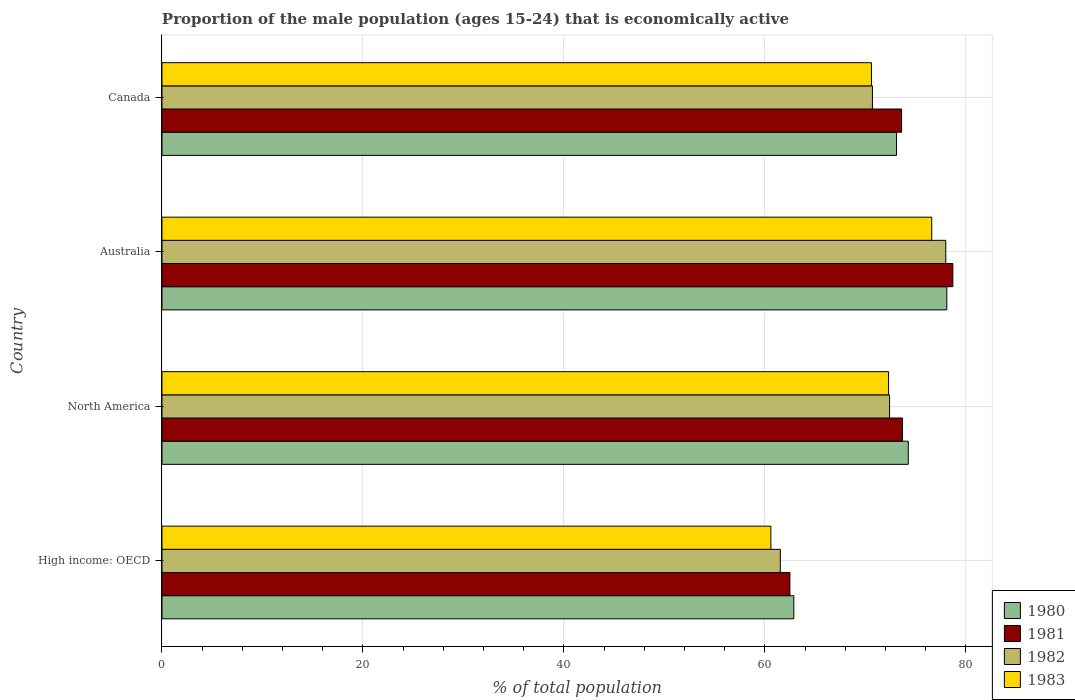How many different coloured bars are there?
Make the answer very short. 4. How many groups of bars are there?
Keep it short and to the point. 4. Are the number of bars per tick equal to the number of legend labels?
Offer a very short reply. Yes. What is the label of the 4th group of bars from the top?
Give a very brief answer. High income: OECD. What is the proportion of the male population that is economically active in 1981 in North America?
Provide a short and direct response. 73.69. Across all countries, what is the maximum proportion of the male population that is economically active in 1982?
Your answer should be compact. 78. Across all countries, what is the minimum proportion of the male population that is economically active in 1980?
Your answer should be compact. 62.88. In which country was the proportion of the male population that is economically active in 1983 minimum?
Make the answer very short. High income: OECD. What is the total proportion of the male population that is economically active in 1982 in the graph?
Your response must be concise. 282.64. What is the difference between the proportion of the male population that is economically active in 1980 in Australia and that in North America?
Your answer should be compact. 3.83. What is the difference between the proportion of the male population that is economically active in 1981 in North America and the proportion of the male population that is economically active in 1980 in Canada?
Ensure brevity in your answer.  0.59. What is the average proportion of the male population that is economically active in 1980 per country?
Ensure brevity in your answer.  72.09. What is the difference between the proportion of the male population that is economically active in 1981 and proportion of the male population that is economically active in 1980 in Australia?
Offer a very short reply. 0.6. What is the ratio of the proportion of the male population that is economically active in 1983 in Canada to that in High income: OECD?
Your response must be concise. 1.17. What is the difference between the highest and the second highest proportion of the male population that is economically active in 1981?
Provide a succinct answer. 5.01. What is the difference between the highest and the lowest proportion of the male population that is economically active in 1983?
Your answer should be compact. 16.01. In how many countries, is the proportion of the male population that is economically active in 1983 greater than the average proportion of the male population that is economically active in 1983 taken over all countries?
Keep it short and to the point. 3. Is it the case that in every country, the sum of the proportion of the male population that is economically active in 1981 and proportion of the male population that is economically active in 1982 is greater than the sum of proportion of the male population that is economically active in 1983 and proportion of the male population that is economically active in 1980?
Ensure brevity in your answer.  No. What does the 4th bar from the bottom in North America represents?
Your answer should be compact. 1983. How many bars are there?
Offer a terse response. 16. Are all the bars in the graph horizontal?
Keep it short and to the point. Yes. What is the difference between two consecutive major ticks on the X-axis?
Keep it short and to the point. 20. Does the graph contain any zero values?
Provide a succinct answer. No. Where does the legend appear in the graph?
Your response must be concise. Bottom right. How are the legend labels stacked?
Offer a very short reply. Vertical. What is the title of the graph?
Provide a succinct answer. Proportion of the male population (ages 15-24) that is economically active. Does "1966" appear as one of the legend labels in the graph?
Offer a terse response. No. What is the label or title of the X-axis?
Your answer should be very brief. % of total population. What is the label or title of the Y-axis?
Offer a terse response. Country. What is the % of total population in 1980 in High income: OECD?
Provide a succinct answer. 62.88. What is the % of total population of 1981 in High income: OECD?
Provide a succinct answer. 62.49. What is the % of total population of 1982 in High income: OECD?
Provide a succinct answer. 61.53. What is the % of total population of 1983 in High income: OECD?
Provide a succinct answer. 60.59. What is the % of total population in 1980 in North America?
Offer a terse response. 74.27. What is the % of total population of 1981 in North America?
Ensure brevity in your answer.  73.69. What is the % of total population in 1982 in North America?
Your answer should be compact. 72.41. What is the % of total population of 1983 in North America?
Your response must be concise. 72.31. What is the % of total population of 1980 in Australia?
Provide a succinct answer. 78.1. What is the % of total population in 1981 in Australia?
Provide a short and direct response. 78.7. What is the % of total population in 1982 in Australia?
Give a very brief answer. 78. What is the % of total population of 1983 in Australia?
Ensure brevity in your answer.  76.6. What is the % of total population in 1980 in Canada?
Give a very brief answer. 73.1. What is the % of total population in 1981 in Canada?
Give a very brief answer. 73.6. What is the % of total population of 1982 in Canada?
Ensure brevity in your answer.  70.7. What is the % of total population in 1983 in Canada?
Your answer should be compact. 70.6. Across all countries, what is the maximum % of total population of 1980?
Your answer should be very brief. 78.1. Across all countries, what is the maximum % of total population of 1981?
Your response must be concise. 78.7. Across all countries, what is the maximum % of total population of 1983?
Make the answer very short. 76.6. Across all countries, what is the minimum % of total population of 1980?
Ensure brevity in your answer.  62.88. Across all countries, what is the minimum % of total population in 1981?
Your answer should be compact. 62.49. Across all countries, what is the minimum % of total population of 1982?
Give a very brief answer. 61.53. Across all countries, what is the minimum % of total population in 1983?
Ensure brevity in your answer.  60.59. What is the total % of total population of 1980 in the graph?
Provide a succinct answer. 288.35. What is the total % of total population of 1981 in the graph?
Provide a succinct answer. 288.48. What is the total % of total population of 1982 in the graph?
Your response must be concise. 282.64. What is the total % of total population of 1983 in the graph?
Offer a terse response. 280.1. What is the difference between the % of total population in 1980 in High income: OECD and that in North America?
Provide a succinct answer. -11.39. What is the difference between the % of total population in 1981 in High income: OECD and that in North America?
Make the answer very short. -11.2. What is the difference between the % of total population of 1982 in High income: OECD and that in North America?
Provide a succinct answer. -10.87. What is the difference between the % of total population of 1983 in High income: OECD and that in North America?
Offer a terse response. -11.71. What is the difference between the % of total population in 1980 in High income: OECD and that in Australia?
Make the answer very short. -15.22. What is the difference between the % of total population of 1981 in High income: OECD and that in Australia?
Your answer should be very brief. -16.21. What is the difference between the % of total population in 1982 in High income: OECD and that in Australia?
Your answer should be compact. -16.47. What is the difference between the % of total population in 1983 in High income: OECD and that in Australia?
Offer a terse response. -16.01. What is the difference between the % of total population in 1980 in High income: OECD and that in Canada?
Your answer should be very brief. -10.22. What is the difference between the % of total population in 1981 in High income: OECD and that in Canada?
Give a very brief answer. -11.11. What is the difference between the % of total population of 1982 in High income: OECD and that in Canada?
Ensure brevity in your answer.  -9.17. What is the difference between the % of total population of 1983 in High income: OECD and that in Canada?
Keep it short and to the point. -10.01. What is the difference between the % of total population in 1980 in North America and that in Australia?
Your answer should be very brief. -3.83. What is the difference between the % of total population in 1981 in North America and that in Australia?
Provide a succinct answer. -5.01. What is the difference between the % of total population of 1982 in North America and that in Australia?
Ensure brevity in your answer.  -5.59. What is the difference between the % of total population in 1983 in North America and that in Australia?
Your answer should be compact. -4.29. What is the difference between the % of total population of 1980 in North America and that in Canada?
Give a very brief answer. 1.17. What is the difference between the % of total population of 1981 in North America and that in Canada?
Keep it short and to the point. 0.09. What is the difference between the % of total population of 1982 in North America and that in Canada?
Your response must be concise. 1.71. What is the difference between the % of total population of 1983 in North America and that in Canada?
Your answer should be compact. 1.71. What is the difference between the % of total population of 1981 in Australia and that in Canada?
Your response must be concise. 5.1. What is the difference between the % of total population in 1983 in Australia and that in Canada?
Your answer should be very brief. 6. What is the difference between the % of total population in 1980 in High income: OECD and the % of total population in 1981 in North America?
Ensure brevity in your answer.  -10.81. What is the difference between the % of total population in 1980 in High income: OECD and the % of total population in 1982 in North America?
Your response must be concise. -9.53. What is the difference between the % of total population in 1980 in High income: OECD and the % of total population in 1983 in North America?
Your answer should be very brief. -9.43. What is the difference between the % of total population in 1981 in High income: OECD and the % of total population in 1982 in North America?
Your answer should be very brief. -9.92. What is the difference between the % of total population in 1981 in High income: OECD and the % of total population in 1983 in North America?
Make the answer very short. -9.82. What is the difference between the % of total population of 1982 in High income: OECD and the % of total population of 1983 in North America?
Ensure brevity in your answer.  -10.77. What is the difference between the % of total population in 1980 in High income: OECD and the % of total population in 1981 in Australia?
Offer a very short reply. -15.82. What is the difference between the % of total population in 1980 in High income: OECD and the % of total population in 1982 in Australia?
Keep it short and to the point. -15.12. What is the difference between the % of total population of 1980 in High income: OECD and the % of total population of 1983 in Australia?
Provide a short and direct response. -13.72. What is the difference between the % of total population of 1981 in High income: OECD and the % of total population of 1982 in Australia?
Offer a very short reply. -15.51. What is the difference between the % of total population of 1981 in High income: OECD and the % of total population of 1983 in Australia?
Provide a short and direct response. -14.11. What is the difference between the % of total population in 1982 in High income: OECD and the % of total population in 1983 in Australia?
Keep it short and to the point. -15.07. What is the difference between the % of total population in 1980 in High income: OECD and the % of total population in 1981 in Canada?
Your response must be concise. -10.72. What is the difference between the % of total population in 1980 in High income: OECD and the % of total population in 1982 in Canada?
Ensure brevity in your answer.  -7.82. What is the difference between the % of total population of 1980 in High income: OECD and the % of total population of 1983 in Canada?
Provide a short and direct response. -7.72. What is the difference between the % of total population in 1981 in High income: OECD and the % of total population in 1982 in Canada?
Your answer should be very brief. -8.21. What is the difference between the % of total population in 1981 in High income: OECD and the % of total population in 1983 in Canada?
Your answer should be compact. -8.11. What is the difference between the % of total population in 1982 in High income: OECD and the % of total population in 1983 in Canada?
Your response must be concise. -9.07. What is the difference between the % of total population of 1980 in North America and the % of total population of 1981 in Australia?
Make the answer very short. -4.43. What is the difference between the % of total population in 1980 in North America and the % of total population in 1982 in Australia?
Your response must be concise. -3.73. What is the difference between the % of total population in 1980 in North America and the % of total population in 1983 in Australia?
Your answer should be very brief. -2.33. What is the difference between the % of total population in 1981 in North America and the % of total population in 1982 in Australia?
Keep it short and to the point. -4.31. What is the difference between the % of total population in 1981 in North America and the % of total population in 1983 in Australia?
Ensure brevity in your answer.  -2.91. What is the difference between the % of total population of 1982 in North America and the % of total population of 1983 in Australia?
Give a very brief answer. -4.19. What is the difference between the % of total population of 1980 in North America and the % of total population of 1981 in Canada?
Ensure brevity in your answer.  0.67. What is the difference between the % of total population of 1980 in North America and the % of total population of 1982 in Canada?
Ensure brevity in your answer.  3.57. What is the difference between the % of total population of 1980 in North America and the % of total population of 1983 in Canada?
Offer a very short reply. 3.67. What is the difference between the % of total population in 1981 in North America and the % of total population in 1982 in Canada?
Provide a short and direct response. 2.99. What is the difference between the % of total population of 1981 in North America and the % of total population of 1983 in Canada?
Offer a terse response. 3.09. What is the difference between the % of total population in 1982 in North America and the % of total population in 1983 in Canada?
Your answer should be very brief. 1.81. What is the difference between the % of total population in 1980 in Australia and the % of total population in 1981 in Canada?
Your response must be concise. 4.5. What is the average % of total population in 1980 per country?
Ensure brevity in your answer.  72.09. What is the average % of total population in 1981 per country?
Your answer should be very brief. 72.12. What is the average % of total population of 1982 per country?
Your response must be concise. 70.66. What is the average % of total population of 1983 per country?
Provide a short and direct response. 70.02. What is the difference between the % of total population of 1980 and % of total population of 1981 in High income: OECD?
Provide a short and direct response. 0.39. What is the difference between the % of total population in 1980 and % of total population in 1982 in High income: OECD?
Keep it short and to the point. 1.34. What is the difference between the % of total population in 1980 and % of total population in 1983 in High income: OECD?
Provide a succinct answer. 2.29. What is the difference between the % of total population of 1981 and % of total population of 1983 in High income: OECD?
Offer a terse response. 1.89. What is the difference between the % of total population of 1982 and % of total population of 1983 in High income: OECD?
Your answer should be very brief. 0.94. What is the difference between the % of total population of 1980 and % of total population of 1981 in North America?
Ensure brevity in your answer.  0.58. What is the difference between the % of total population in 1980 and % of total population in 1982 in North America?
Provide a short and direct response. 1.86. What is the difference between the % of total population in 1980 and % of total population in 1983 in North America?
Provide a short and direct response. 1.96. What is the difference between the % of total population in 1981 and % of total population in 1982 in North America?
Give a very brief answer. 1.28. What is the difference between the % of total population of 1981 and % of total population of 1983 in North America?
Make the answer very short. 1.38. What is the difference between the % of total population of 1982 and % of total population of 1983 in North America?
Your answer should be compact. 0.1. What is the difference between the % of total population in 1980 and % of total population in 1983 in Australia?
Your answer should be very brief. 1.5. What is the difference between the % of total population of 1981 and % of total population of 1982 in Australia?
Provide a succinct answer. 0.7. What is the difference between the % of total population of 1980 and % of total population of 1981 in Canada?
Offer a terse response. -0.5. What is the difference between the % of total population of 1980 and % of total population of 1982 in Canada?
Keep it short and to the point. 2.4. What is the difference between the % of total population in 1980 and % of total population in 1983 in Canada?
Provide a succinct answer. 2.5. What is the difference between the % of total population in 1981 and % of total population in 1983 in Canada?
Provide a short and direct response. 3. What is the difference between the % of total population in 1982 and % of total population in 1983 in Canada?
Provide a short and direct response. 0.1. What is the ratio of the % of total population of 1980 in High income: OECD to that in North America?
Ensure brevity in your answer.  0.85. What is the ratio of the % of total population of 1981 in High income: OECD to that in North America?
Provide a short and direct response. 0.85. What is the ratio of the % of total population of 1982 in High income: OECD to that in North America?
Give a very brief answer. 0.85. What is the ratio of the % of total population in 1983 in High income: OECD to that in North America?
Provide a succinct answer. 0.84. What is the ratio of the % of total population in 1980 in High income: OECD to that in Australia?
Ensure brevity in your answer.  0.81. What is the ratio of the % of total population in 1981 in High income: OECD to that in Australia?
Offer a very short reply. 0.79. What is the ratio of the % of total population in 1982 in High income: OECD to that in Australia?
Make the answer very short. 0.79. What is the ratio of the % of total population in 1983 in High income: OECD to that in Australia?
Make the answer very short. 0.79. What is the ratio of the % of total population in 1980 in High income: OECD to that in Canada?
Give a very brief answer. 0.86. What is the ratio of the % of total population in 1981 in High income: OECD to that in Canada?
Give a very brief answer. 0.85. What is the ratio of the % of total population of 1982 in High income: OECD to that in Canada?
Give a very brief answer. 0.87. What is the ratio of the % of total population of 1983 in High income: OECD to that in Canada?
Provide a succinct answer. 0.86. What is the ratio of the % of total population of 1980 in North America to that in Australia?
Your answer should be very brief. 0.95. What is the ratio of the % of total population in 1981 in North America to that in Australia?
Provide a short and direct response. 0.94. What is the ratio of the % of total population of 1982 in North America to that in Australia?
Provide a short and direct response. 0.93. What is the ratio of the % of total population in 1983 in North America to that in Australia?
Provide a succinct answer. 0.94. What is the ratio of the % of total population in 1982 in North America to that in Canada?
Ensure brevity in your answer.  1.02. What is the ratio of the % of total population in 1983 in North America to that in Canada?
Your answer should be compact. 1.02. What is the ratio of the % of total population of 1980 in Australia to that in Canada?
Ensure brevity in your answer.  1.07. What is the ratio of the % of total population of 1981 in Australia to that in Canada?
Make the answer very short. 1.07. What is the ratio of the % of total population in 1982 in Australia to that in Canada?
Offer a terse response. 1.1. What is the ratio of the % of total population of 1983 in Australia to that in Canada?
Make the answer very short. 1.08. What is the difference between the highest and the second highest % of total population of 1980?
Provide a succinct answer. 3.83. What is the difference between the highest and the second highest % of total population of 1981?
Make the answer very short. 5.01. What is the difference between the highest and the second highest % of total population of 1982?
Give a very brief answer. 5.59. What is the difference between the highest and the second highest % of total population of 1983?
Ensure brevity in your answer.  4.29. What is the difference between the highest and the lowest % of total population of 1980?
Give a very brief answer. 15.22. What is the difference between the highest and the lowest % of total population in 1981?
Your response must be concise. 16.21. What is the difference between the highest and the lowest % of total population in 1982?
Provide a succinct answer. 16.47. What is the difference between the highest and the lowest % of total population in 1983?
Provide a succinct answer. 16.01. 